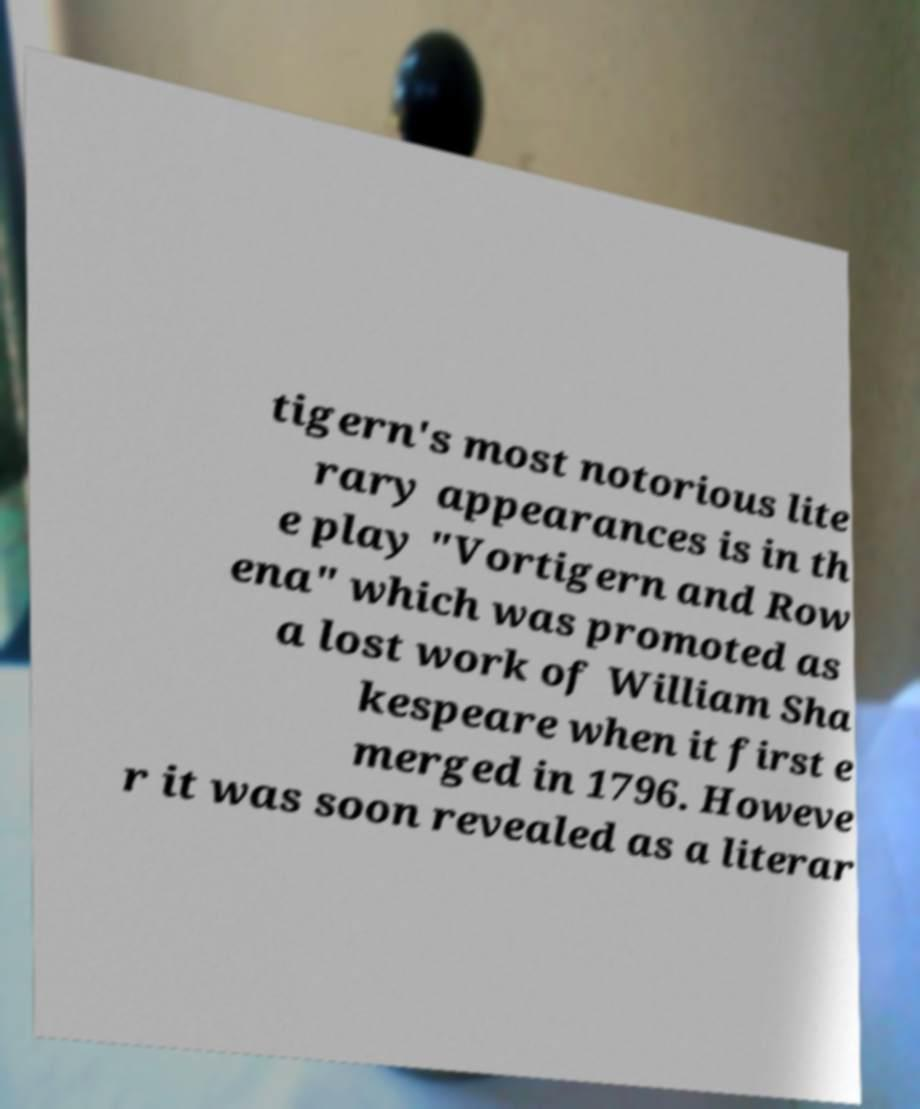Could you assist in decoding the text presented in this image and type it out clearly? tigern's most notorious lite rary appearances is in th e play "Vortigern and Row ena" which was promoted as a lost work of William Sha kespeare when it first e merged in 1796. Howeve r it was soon revealed as a literar 